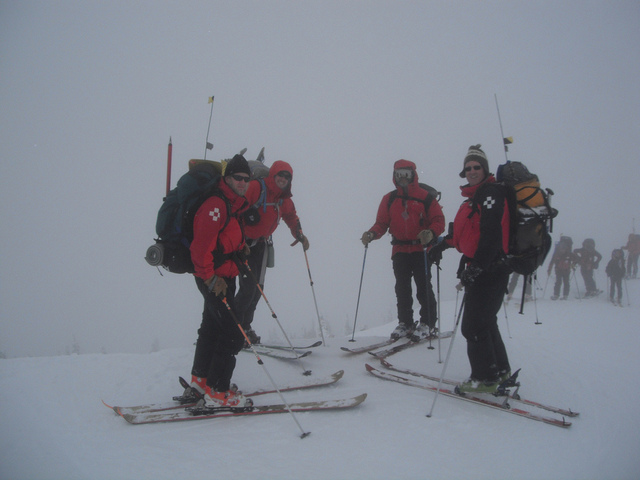<image>What brand are their jackets? I don't know what brand are their jackets. They can be 'under armour', '4 square', 'north face', 'medical', 'swiss', 'columbia' or 'athletic'. What brand are their jackets? I am not sure what brand their jackets are. It can be seen 'under armour', "don't know", '4 square', 'north face', 'medical', 'swiss', 'columbia' or 'athletic'. 